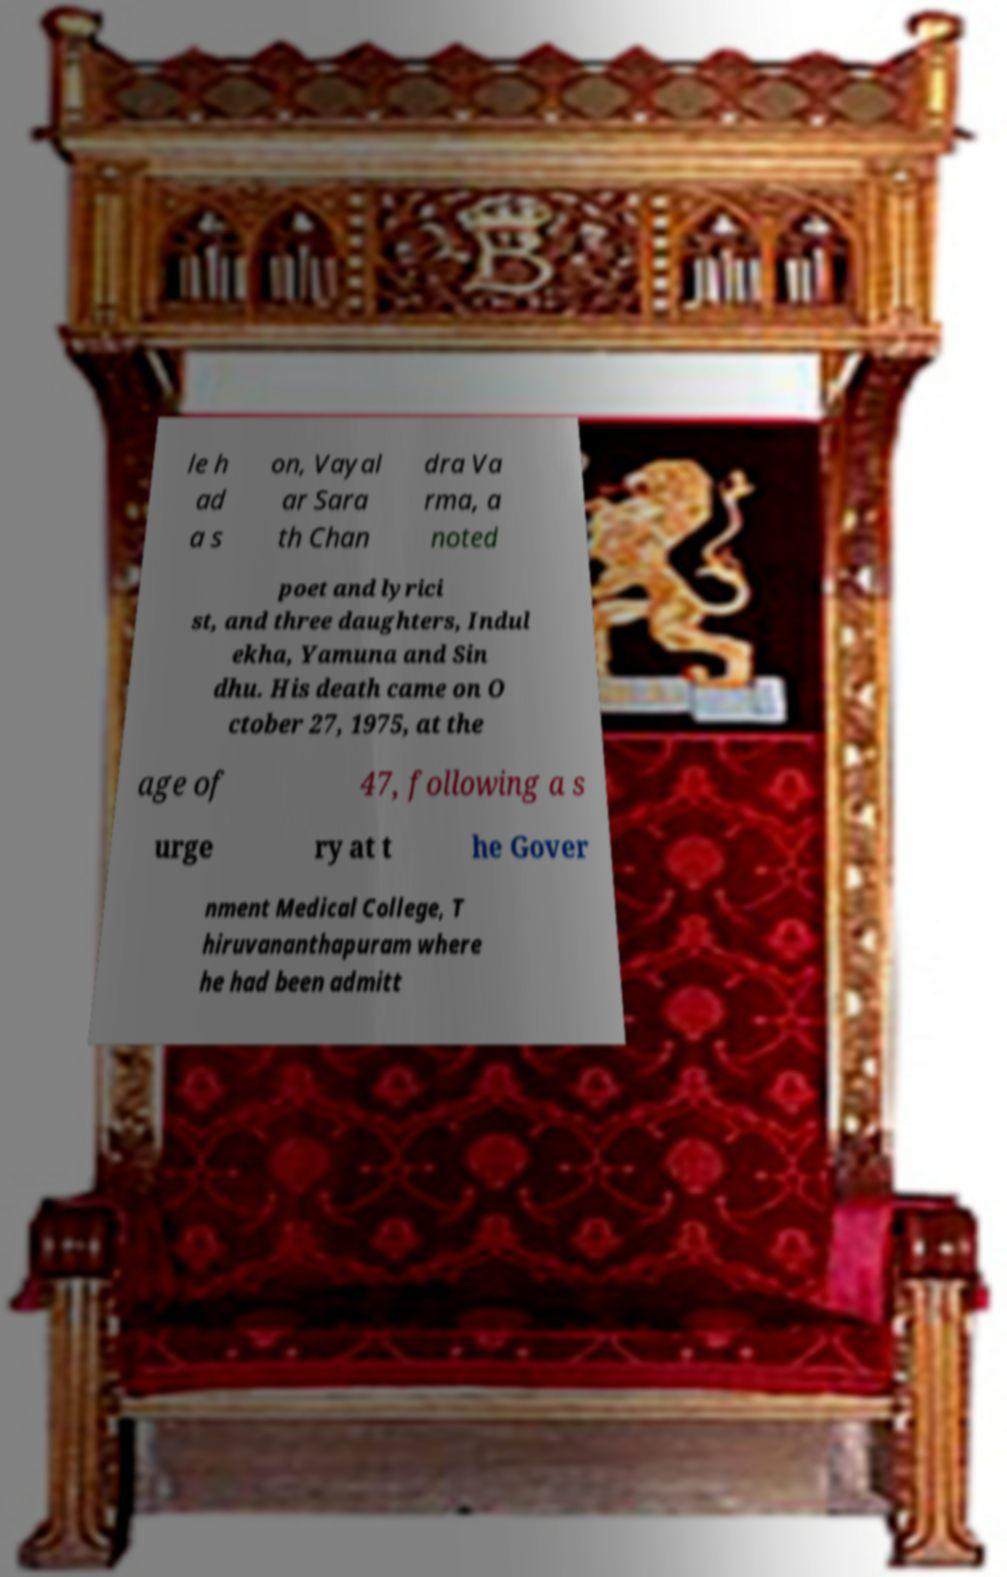I need the written content from this picture converted into text. Can you do that? le h ad a s on, Vayal ar Sara th Chan dra Va rma, a noted poet and lyrici st, and three daughters, Indul ekha, Yamuna and Sin dhu. His death came on O ctober 27, 1975, at the age of 47, following a s urge ry at t he Gover nment Medical College, T hiruvananthapuram where he had been admitt 